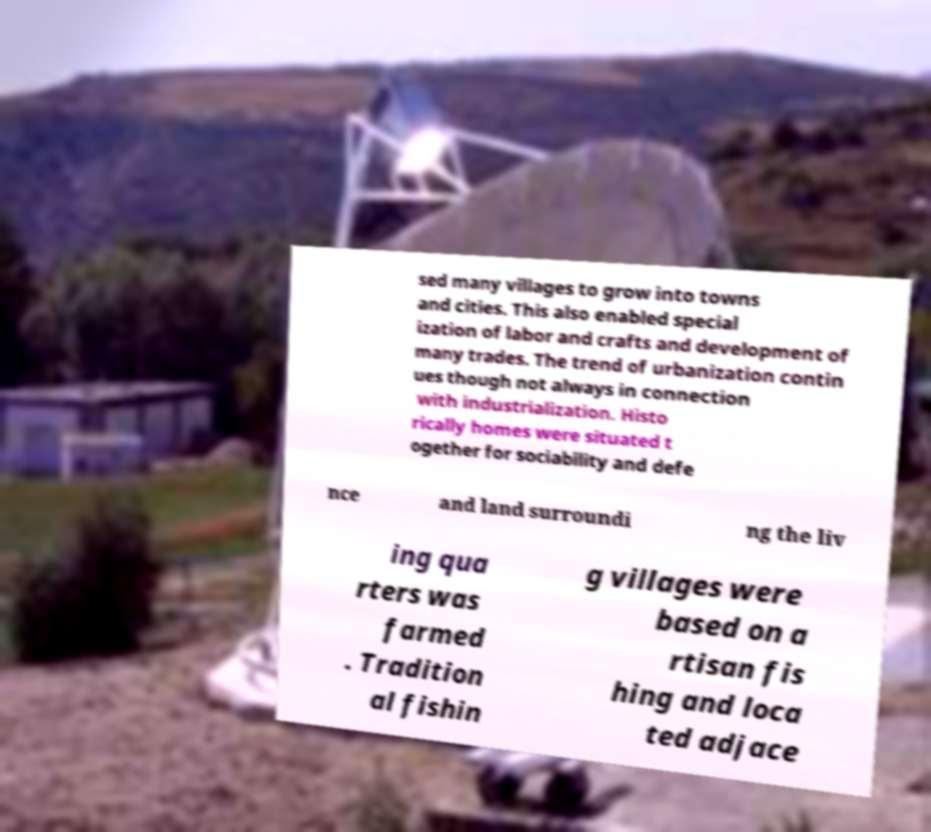Please read and relay the text visible in this image. What does it say? sed many villages to grow into towns and cities. This also enabled special ization of labor and crafts and development of many trades. The trend of urbanization contin ues though not always in connection with industrialization. Histo rically homes were situated t ogether for sociability and defe nce and land surroundi ng the liv ing qua rters was farmed . Tradition al fishin g villages were based on a rtisan fis hing and loca ted adjace 